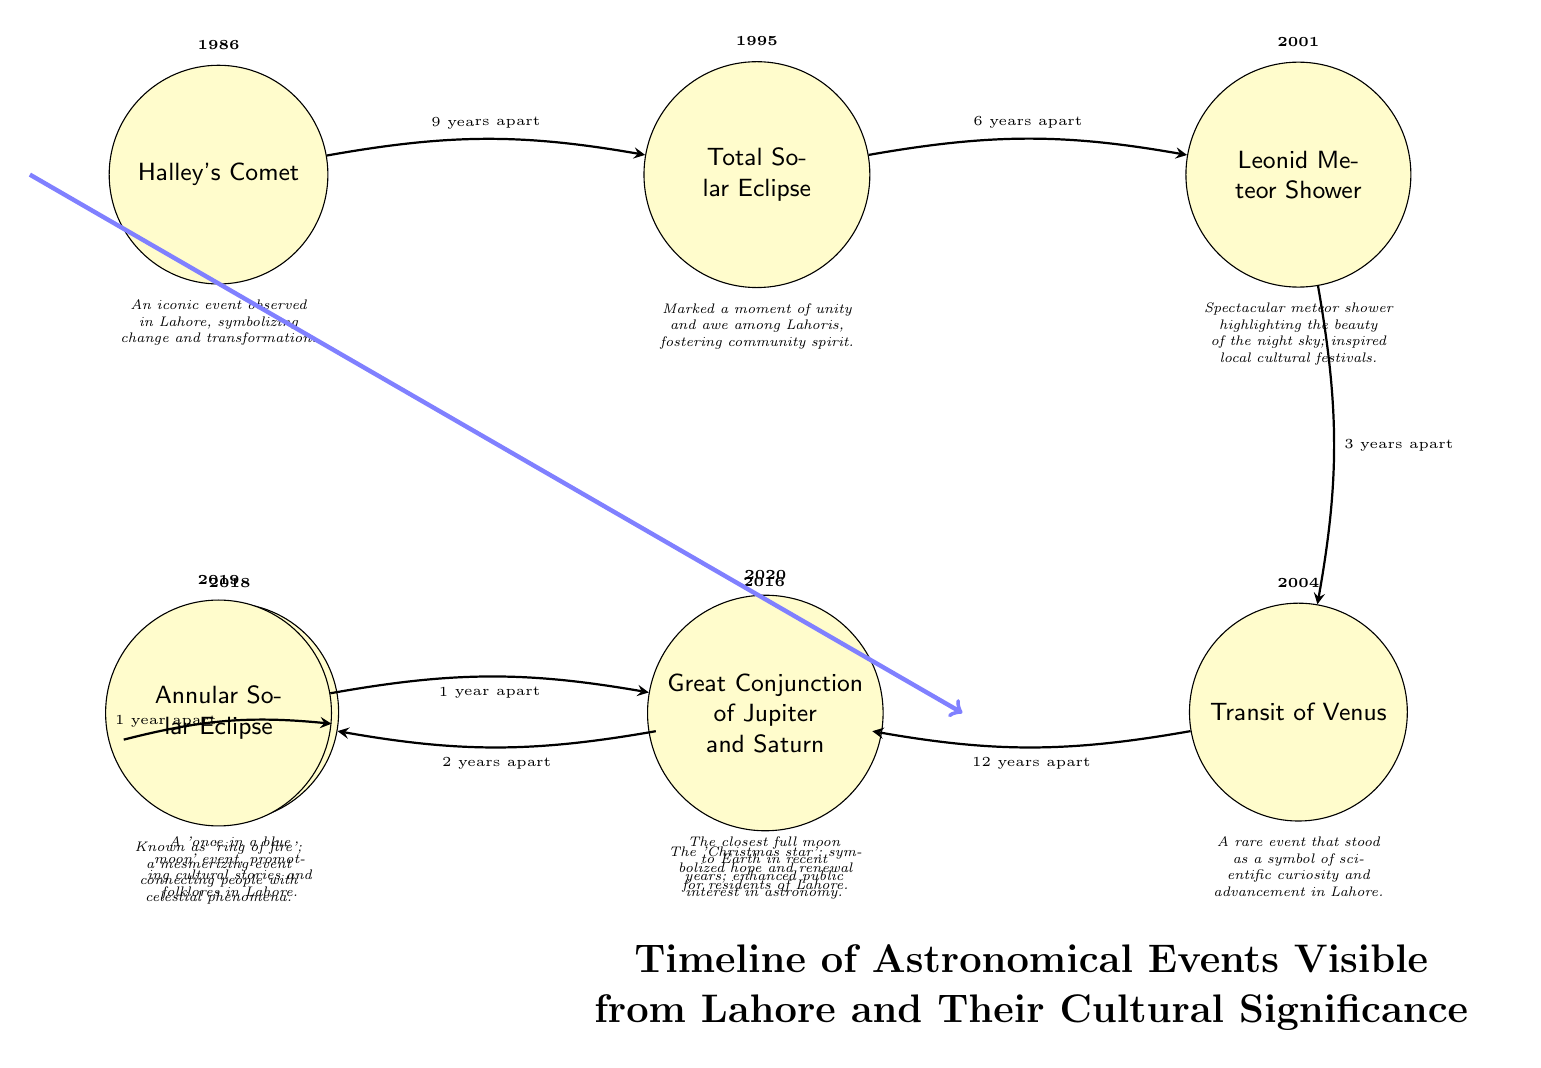What astronomical event occurred in 1986? The diagram explicitly labels the event in the circle designated for that year. It shows "Halley's Comet."
Answer: Halley's Comet How many years apart are the Total Solar Eclipse and the Leonid Meteor Shower? The arrows connecting these two events indicate the time difference labeled as "6 years apart."
Answer: 6 years Which event in the timeline is associated with scientific curiosity? By examining the descriptions under each event, the "Transit of Venus" is indicated as a symbol of scientific curiosity and advancement in Lahore.
Answer: Transit of Venus What was the cultural significance of the Great Conjunction of Jupiter and Saturn? The description under this event references it as the "Christmas star," symbolizing hope and renewal for residents of Lahore, highlighting its cultural importance.
Answer: Hope and renewal Which event follows the Supermoon in the timeline? Looking at the directional arrows, the event that follows the Supermoon (2016) is the Blue Moon (2018).
Answer: Blue Moon How many events are there in total on the timeline? Counting the events shown in the diagram (Halley's Comet, Total Solar Eclipse, Leonid Meteor Shower, Transit of Venus, Supermoon, Blue Moon, Annular Solar Eclipse, Great Conjunction), there are eight events total.
Answer: 8 What cultural phenomenon did the Leonid Meteor Shower inspire? The diagram describes the Leonid Meteor Shower as highlighting the beauty of the night sky and inspiring local cultural festivals.
Answer: Cultural festivals What unique feature does the Annular Solar Eclipse represent? The event is specifically noted as the "ring of fire," which is a distinct characteristic of an annular solar eclipse.
Answer: Ring of fire 